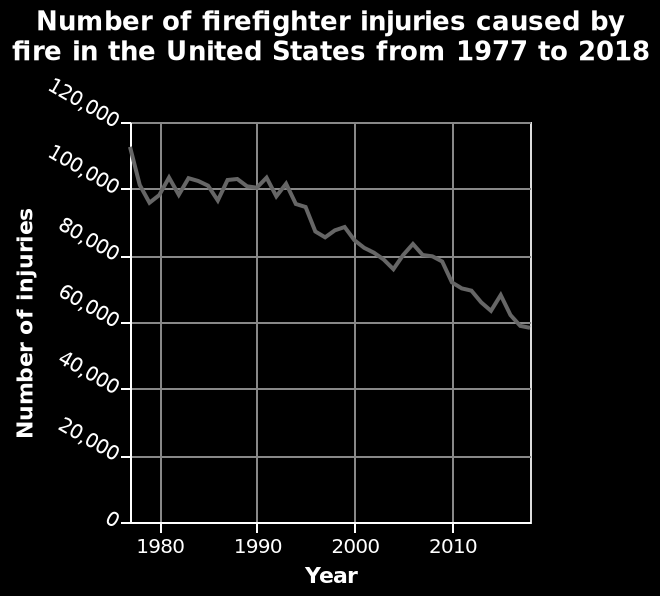<image>
What is the trend in the number of firefighters injured over time? The trend shows a decrease in the number of firefighters injured, with a sharp decrease between 1977 and 1980, variation between 1980 and the early 1990s, and a general downward trend afterwards. 